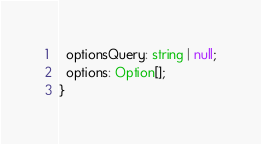<code> <loc_0><loc_0><loc_500><loc_500><_TypeScript_>  optionsQuery: string | null;
  options: Option[];
}
</code> 